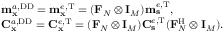Convert formula to latex. <formula><loc_0><loc_0><loc_500><loc_500>\begin{array} { r l } & { m _ { x } ^ { a , D D } = m _ { x } ^ { e , T } = ( F _ { N } \otimes I _ { M } ) m _ { s } ^ { e , T } , } \\ & { C _ { x } ^ { a , D D } = C _ { x } ^ { e , T } = ( F _ { N } \otimes I _ { M } ) C _ { s } ^ { e , T } ( F _ { N } ^ { H } \otimes I _ { M } ) . } \end{array}</formula> 